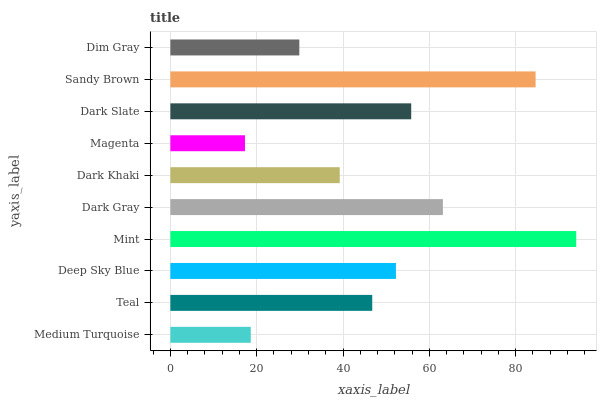Is Magenta the minimum?
Answer yes or no. Yes. Is Mint the maximum?
Answer yes or no. Yes. Is Teal the minimum?
Answer yes or no. No. Is Teal the maximum?
Answer yes or no. No. Is Teal greater than Medium Turquoise?
Answer yes or no. Yes. Is Medium Turquoise less than Teal?
Answer yes or no. Yes. Is Medium Turquoise greater than Teal?
Answer yes or no. No. Is Teal less than Medium Turquoise?
Answer yes or no. No. Is Deep Sky Blue the high median?
Answer yes or no. Yes. Is Teal the low median?
Answer yes or no. Yes. Is Dark Khaki the high median?
Answer yes or no. No. Is Medium Turquoise the low median?
Answer yes or no. No. 